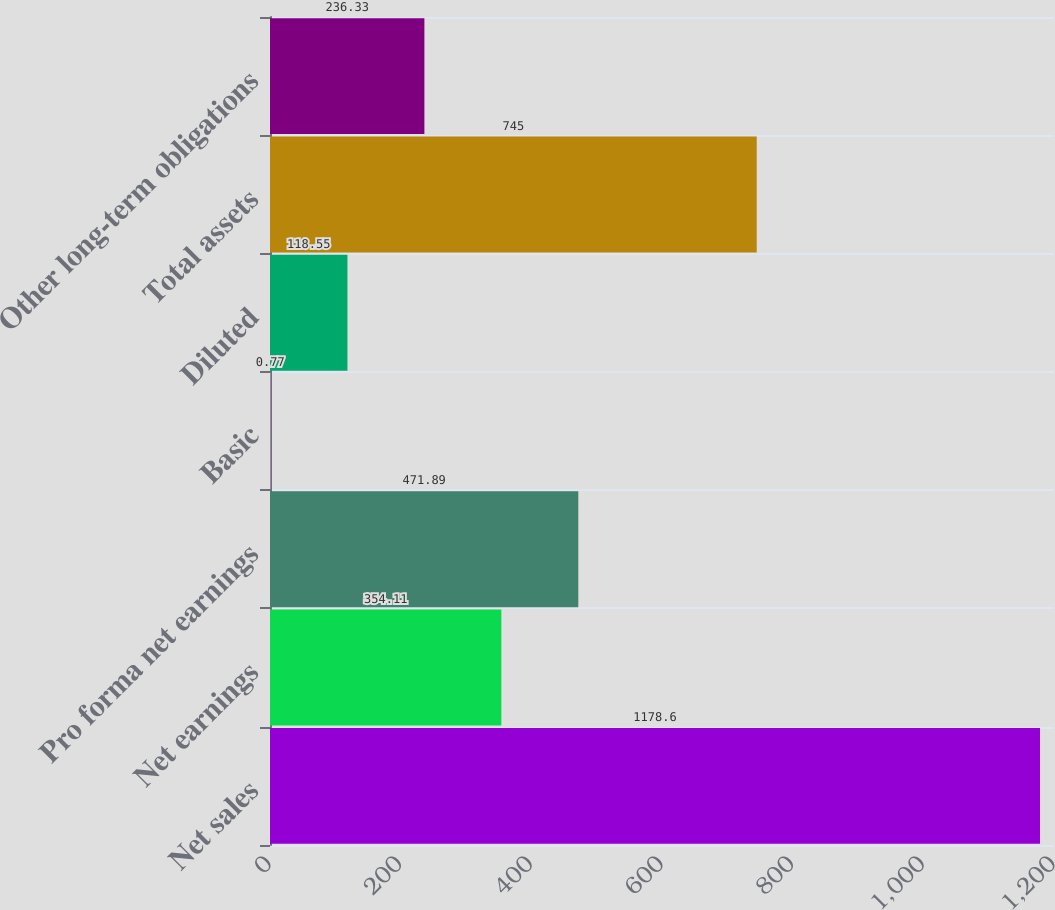Convert chart to OTSL. <chart><loc_0><loc_0><loc_500><loc_500><bar_chart><fcel>Net sales<fcel>Net earnings<fcel>Pro forma net earnings<fcel>Basic<fcel>Diluted<fcel>Total assets<fcel>Other long-term obligations<nl><fcel>1178.6<fcel>354.11<fcel>471.89<fcel>0.77<fcel>118.55<fcel>745<fcel>236.33<nl></chart> 